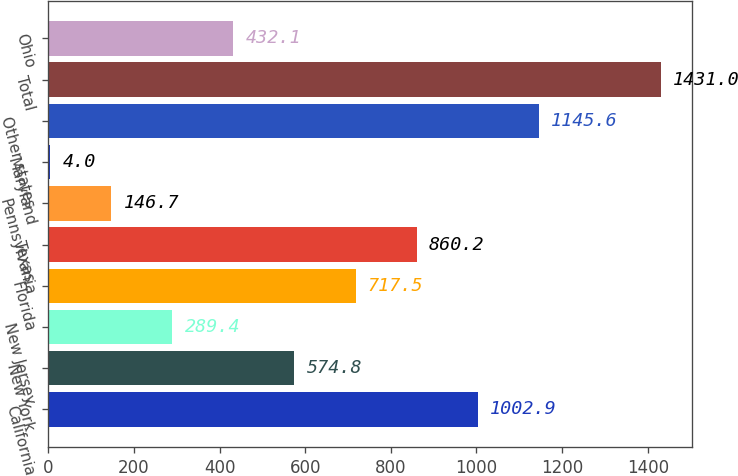Convert chart. <chart><loc_0><loc_0><loc_500><loc_500><bar_chart><fcel>California<fcel>New York<fcel>New Jersey<fcel>Florida<fcel>Texas<fcel>Pennsylvania<fcel>Maryland<fcel>Other states<fcel>Total<fcel>Ohio<nl><fcel>1002.9<fcel>574.8<fcel>289.4<fcel>717.5<fcel>860.2<fcel>146.7<fcel>4<fcel>1145.6<fcel>1431<fcel>432.1<nl></chart> 